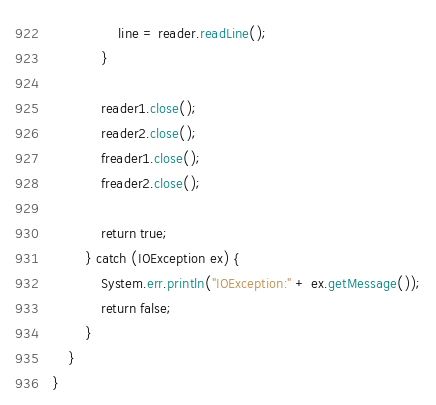Convert code to text. <code><loc_0><loc_0><loc_500><loc_500><_Java_>                line = reader.readLine();
            }

            reader1.close();
            reader2.close();
            freader1.close();
            freader2.close();

            return true;
        } catch (IOException ex) {
            System.err.println("IOException:" + ex.getMessage());
            return false;
        }
    }
}
</code> 